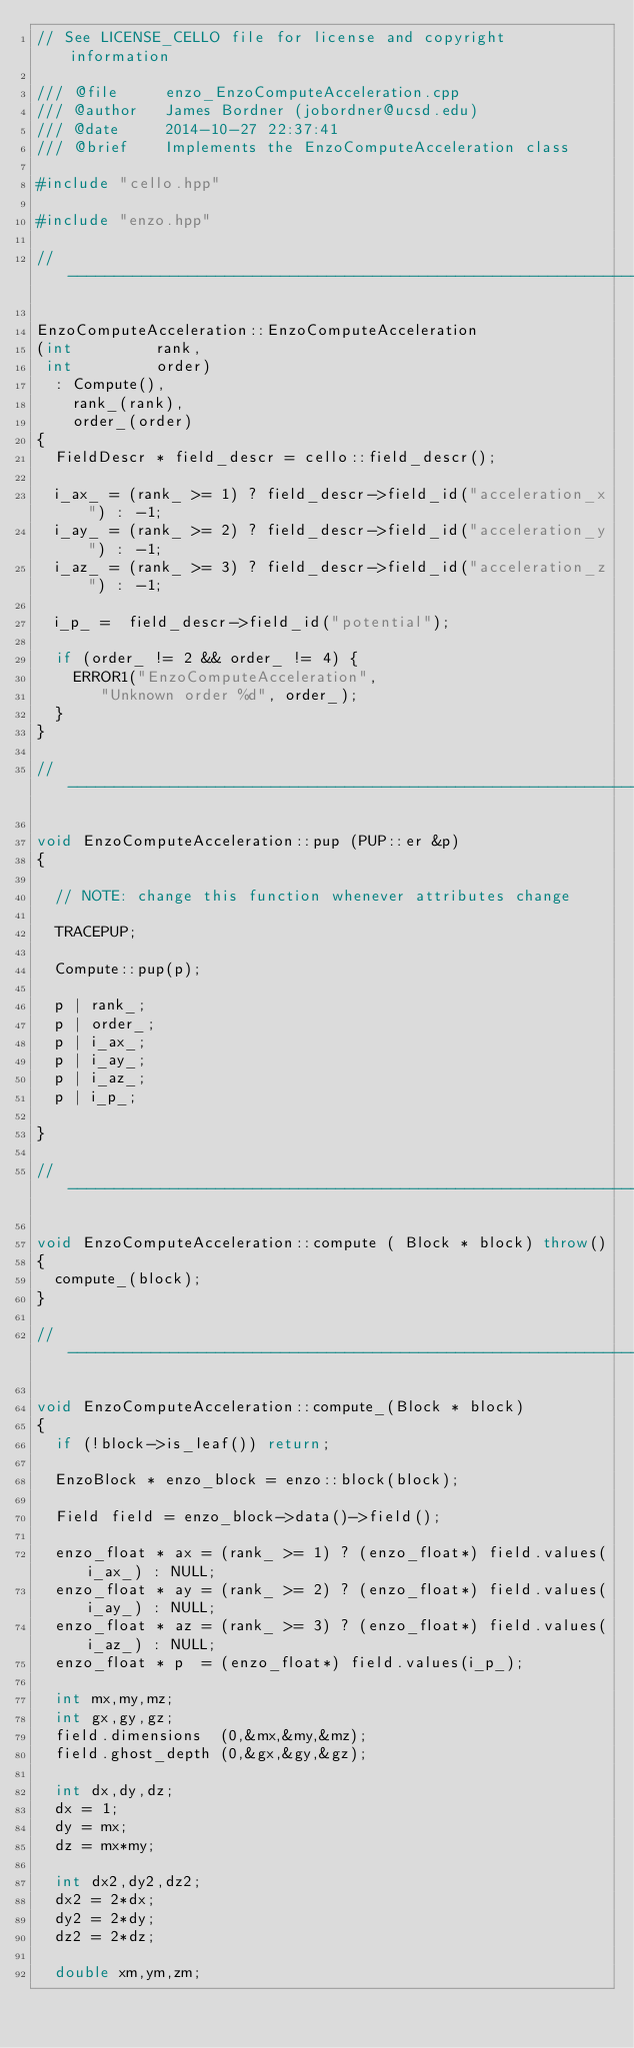<code> <loc_0><loc_0><loc_500><loc_500><_C++_>// See LICENSE_CELLO file for license and copyright information

/// @file     enzo_EnzoComputeAcceleration.cpp
/// @author   James Bordner (jobordner@ucsd.edu)
/// @date     2014-10-27 22:37:41
/// @brief    Implements the EnzoComputeAcceleration class

#include "cello.hpp"

#include "enzo.hpp"

//----------------------------------------------------------------------

EnzoComputeAcceleration::EnzoComputeAcceleration
(int         rank,
 int         order)
  : Compute(),
    rank_(rank),
    order_(order)
{
  FieldDescr * field_descr = cello::field_descr();

  i_ax_ = (rank_ >= 1) ? field_descr->field_id("acceleration_x") : -1;
  i_ay_ = (rank_ >= 2) ? field_descr->field_id("acceleration_y") : -1;
  i_az_ = (rank_ >= 3) ? field_descr->field_id("acceleration_z") : -1;

  i_p_ =  field_descr->field_id("potential");

  if (order_ != 2 && order_ != 4) {
    ERROR1("EnzoComputeAcceleration",
	   "Unknown order %d", order_);
  }
}

//----------------------------------------------------------------------

void EnzoComputeAcceleration::pup (PUP::er &p)
{

  // NOTE: change this function whenever attributes change

  TRACEPUP;

  Compute::pup(p);

  p | rank_;
  p | order_;
  p | i_ax_;
  p | i_ay_;
  p | i_az_;
  p | i_p_;

}

//----------------------------------------------------------------------

void EnzoComputeAcceleration::compute ( Block * block) throw()
{
  compute_(block);
}

//----------------------------------------------------------------------

void EnzoComputeAcceleration::compute_(Block * block)
{
  if (!block->is_leaf()) return;

  EnzoBlock * enzo_block = enzo::block(block);

  Field field = enzo_block->data()->field();

  enzo_float * ax = (rank_ >= 1) ? (enzo_float*) field.values(i_ax_) : NULL;
  enzo_float * ay = (rank_ >= 2) ? (enzo_float*) field.values(i_ay_) : NULL;
  enzo_float * az = (rank_ >= 3) ? (enzo_float*) field.values(i_az_) : NULL;
  enzo_float * p  = (enzo_float*) field.values(i_p_);

  int mx,my,mz;
  int gx,gy,gz;
  field.dimensions  (0,&mx,&my,&mz);
  field.ghost_depth (0,&gx,&gy,&gz);

  int dx,dy,dz;
  dx = 1;
  dy = mx;
  dz = mx*my;

  int dx2,dy2,dz2;
  dx2 = 2*dx;
  dy2 = 2*dy;
  dz2 = 2*dz;

  double xm,ym,zm;</code> 